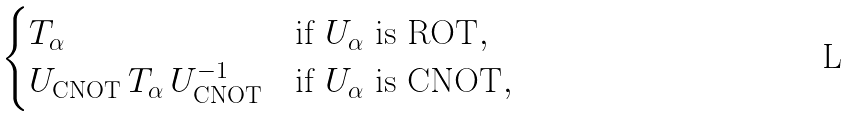Convert formula to latex. <formula><loc_0><loc_0><loc_500><loc_500>\begin{cases} T _ { \alpha } & \text {if $U_{\alpha}$ is ROT} , \\ U _ { \text {CNOT} } \, T _ { \alpha } \, U _ { \text {CNOT} } ^ { - 1 } & \text {if $U_{\alpha}$ is CNOT} , \end{cases}</formula> 